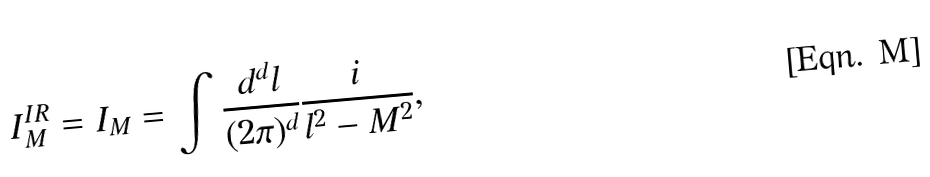Convert formula to latex. <formula><loc_0><loc_0><loc_500><loc_500>I _ { M } ^ { I R } = I _ { M } = \int \frac { d ^ { d } l } { ( 2 \pi ) ^ { d } } \frac { i } { l ^ { 2 } - M ^ { 2 } } ,</formula> 